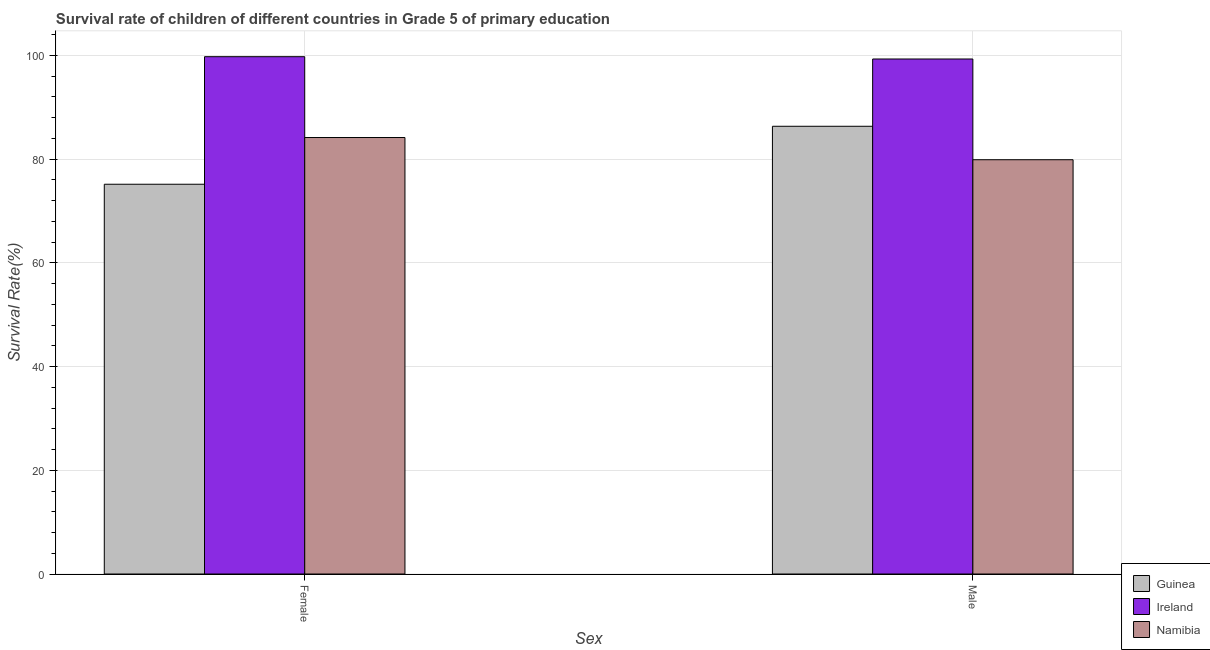Are the number of bars on each tick of the X-axis equal?
Your response must be concise. Yes. What is the survival rate of female students in primary education in Namibia?
Offer a very short reply. 84.16. Across all countries, what is the maximum survival rate of male students in primary education?
Provide a short and direct response. 99.3. Across all countries, what is the minimum survival rate of female students in primary education?
Provide a short and direct response. 75.15. In which country was the survival rate of male students in primary education maximum?
Your answer should be very brief. Ireland. In which country was the survival rate of female students in primary education minimum?
Provide a short and direct response. Guinea. What is the total survival rate of female students in primary education in the graph?
Your answer should be compact. 259.04. What is the difference between the survival rate of male students in primary education in Ireland and that in Guinea?
Offer a terse response. 12.97. What is the difference between the survival rate of female students in primary education in Namibia and the survival rate of male students in primary education in Ireland?
Offer a terse response. -15.14. What is the average survival rate of male students in primary education per country?
Provide a succinct answer. 88.5. What is the difference between the survival rate of female students in primary education and survival rate of male students in primary education in Namibia?
Your response must be concise. 4.28. In how many countries, is the survival rate of female students in primary education greater than 96 %?
Give a very brief answer. 1. What is the ratio of the survival rate of female students in primary education in Guinea to that in Namibia?
Keep it short and to the point. 0.89. What does the 1st bar from the left in Female represents?
Offer a terse response. Guinea. What does the 1st bar from the right in Male represents?
Offer a very short reply. Namibia. What is the difference between two consecutive major ticks on the Y-axis?
Make the answer very short. 20. Where does the legend appear in the graph?
Offer a very short reply. Bottom right. What is the title of the graph?
Your answer should be very brief. Survival rate of children of different countries in Grade 5 of primary education. What is the label or title of the X-axis?
Keep it short and to the point. Sex. What is the label or title of the Y-axis?
Your answer should be compact. Survival Rate(%). What is the Survival Rate(%) in Guinea in Female?
Make the answer very short. 75.15. What is the Survival Rate(%) of Ireland in Female?
Offer a terse response. 99.74. What is the Survival Rate(%) of Namibia in Female?
Provide a succinct answer. 84.16. What is the Survival Rate(%) in Guinea in Male?
Make the answer very short. 86.32. What is the Survival Rate(%) of Ireland in Male?
Provide a succinct answer. 99.3. What is the Survival Rate(%) in Namibia in Male?
Offer a terse response. 79.87. Across all Sex, what is the maximum Survival Rate(%) in Guinea?
Give a very brief answer. 86.32. Across all Sex, what is the maximum Survival Rate(%) of Ireland?
Your answer should be compact. 99.74. Across all Sex, what is the maximum Survival Rate(%) in Namibia?
Make the answer very short. 84.16. Across all Sex, what is the minimum Survival Rate(%) in Guinea?
Offer a terse response. 75.15. Across all Sex, what is the minimum Survival Rate(%) in Ireland?
Offer a very short reply. 99.3. Across all Sex, what is the minimum Survival Rate(%) of Namibia?
Your answer should be very brief. 79.87. What is the total Survival Rate(%) of Guinea in the graph?
Your answer should be compact. 161.47. What is the total Survival Rate(%) in Ireland in the graph?
Ensure brevity in your answer.  199.04. What is the total Survival Rate(%) of Namibia in the graph?
Provide a succinct answer. 164.03. What is the difference between the Survival Rate(%) of Guinea in Female and that in Male?
Give a very brief answer. -11.17. What is the difference between the Survival Rate(%) in Ireland in Female and that in Male?
Offer a very short reply. 0.44. What is the difference between the Survival Rate(%) in Namibia in Female and that in Male?
Your answer should be compact. 4.28. What is the difference between the Survival Rate(%) in Guinea in Female and the Survival Rate(%) in Ireland in Male?
Keep it short and to the point. -24.15. What is the difference between the Survival Rate(%) in Guinea in Female and the Survival Rate(%) in Namibia in Male?
Provide a succinct answer. -4.73. What is the difference between the Survival Rate(%) of Ireland in Female and the Survival Rate(%) of Namibia in Male?
Offer a terse response. 19.87. What is the average Survival Rate(%) in Guinea per Sex?
Provide a short and direct response. 80.74. What is the average Survival Rate(%) of Ireland per Sex?
Offer a very short reply. 99.52. What is the average Survival Rate(%) in Namibia per Sex?
Offer a very short reply. 82.01. What is the difference between the Survival Rate(%) of Guinea and Survival Rate(%) of Ireland in Female?
Keep it short and to the point. -24.59. What is the difference between the Survival Rate(%) of Guinea and Survival Rate(%) of Namibia in Female?
Your response must be concise. -9.01. What is the difference between the Survival Rate(%) in Ireland and Survival Rate(%) in Namibia in Female?
Offer a very short reply. 15.58. What is the difference between the Survival Rate(%) of Guinea and Survival Rate(%) of Ireland in Male?
Offer a very short reply. -12.97. What is the difference between the Survival Rate(%) of Guinea and Survival Rate(%) of Namibia in Male?
Your response must be concise. 6.45. What is the difference between the Survival Rate(%) of Ireland and Survival Rate(%) of Namibia in Male?
Give a very brief answer. 19.42. What is the ratio of the Survival Rate(%) in Guinea in Female to that in Male?
Your response must be concise. 0.87. What is the ratio of the Survival Rate(%) in Ireland in Female to that in Male?
Offer a terse response. 1. What is the ratio of the Survival Rate(%) of Namibia in Female to that in Male?
Keep it short and to the point. 1.05. What is the difference between the highest and the second highest Survival Rate(%) of Guinea?
Give a very brief answer. 11.17. What is the difference between the highest and the second highest Survival Rate(%) of Ireland?
Offer a terse response. 0.44. What is the difference between the highest and the second highest Survival Rate(%) in Namibia?
Ensure brevity in your answer.  4.28. What is the difference between the highest and the lowest Survival Rate(%) of Guinea?
Your response must be concise. 11.17. What is the difference between the highest and the lowest Survival Rate(%) of Ireland?
Your response must be concise. 0.44. What is the difference between the highest and the lowest Survival Rate(%) in Namibia?
Offer a terse response. 4.28. 